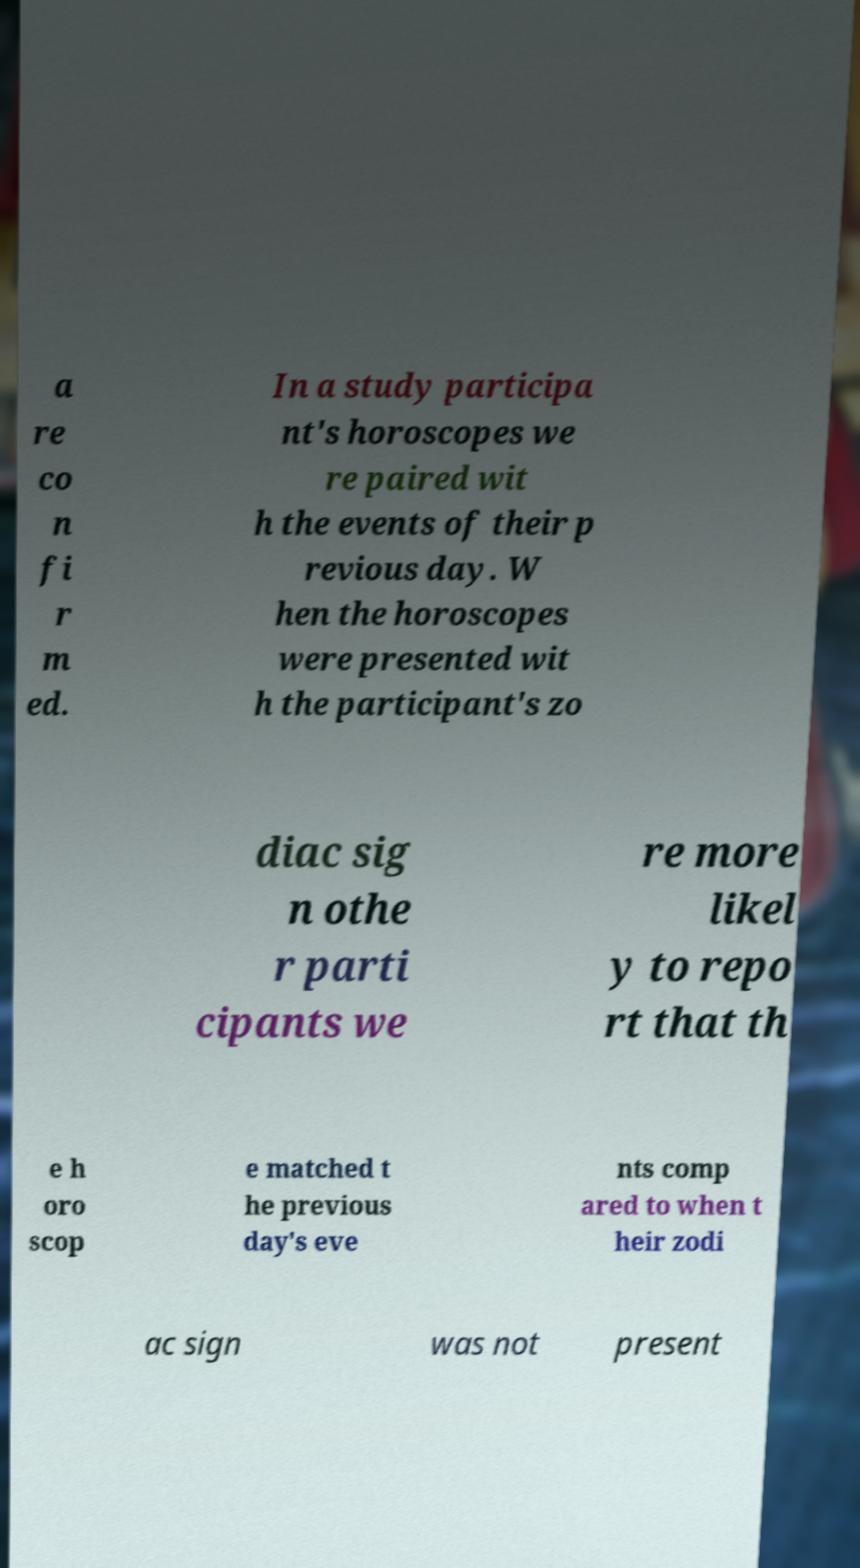I need the written content from this picture converted into text. Can you do that? a re co n fi r m ed. In a study participa nt's horoscopes we re paired wit h the events of their p revious day. W hen the horoscopes were presented wit h the participant's zo diac sig n othe r parti cipants we re more likel y to repo rt that th e h oro scop e matched t he previous day's eve nts comp ared to when t heir zodi ac sign was not present 